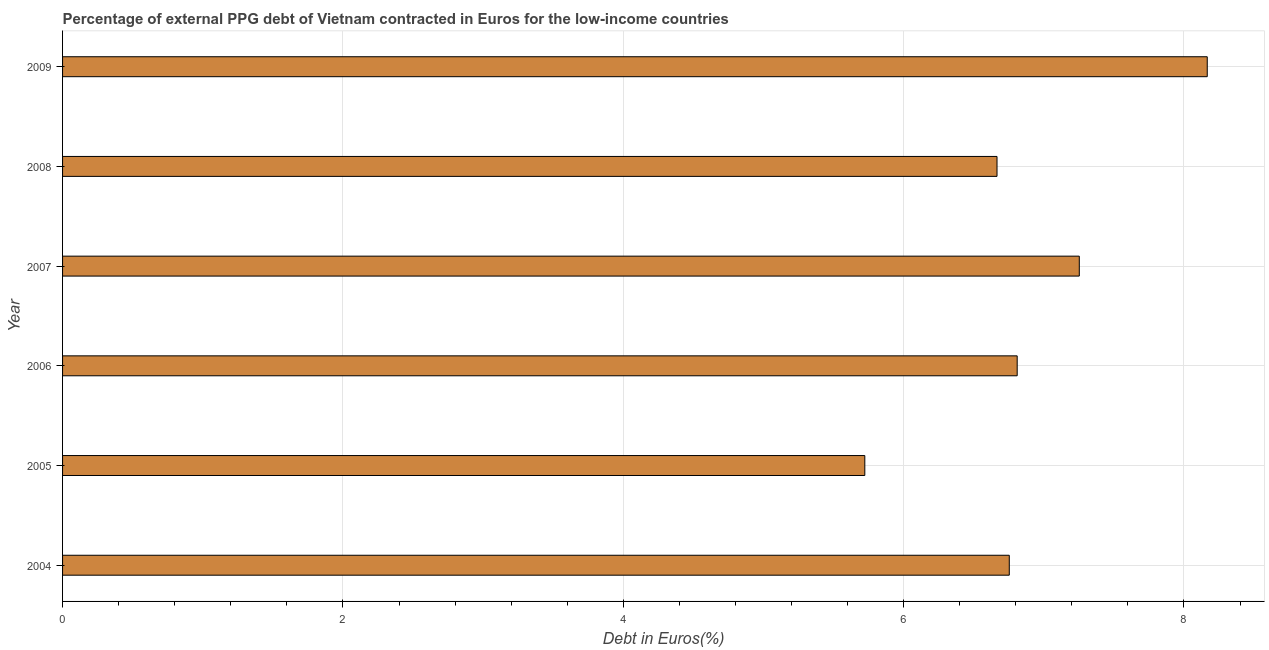Does the graph contain any zero values?
Your answer should be compact. No. Does the graph contain grids?
Give a very brief answer. Yes. What is the title of the graph?
Provide a succinct answer. Percentage of external PPG debt of Vietnam contracted in Euros for the low-income countries. What is the label or title of the X-axis?
Offer a terse response. Debt in Euros(%). What is the label or title of the Y-axis?
Ensure brevity in your answer.  Year. What is the currency composition of ppg debt in 2009?
Give a very brief answer. 8.17. Across all years, what is the maximum currency composition of ppg debt?
Provide a short and direct response. 8.17. Across all years, what is the minimum currency composition of ppg debt?
Your answer should be compact. 5.72. What is the sum of the currency composition of ppg debt?
Offer a terse response. 41.37. What is the difference between the currency composition of ppg debt in 2004 and 2008?
Ensure brevity in your answer.  0.09. What is the average currency composition of ppg debt per year?
Your answer should be compact. 6.89. What is the median currency composition of ppg debt?
Your answer should be compact. 6.78. What is the ratio of the currency composition of ppg debt in 2005 to that in 2006?
Your answer should be very brief. 0.84. Is the currency composition of ppg debt in 2007 less than that in 2009?
Your answer should be very brief. Yes. What is the difference between the highest and the second highest currency composition of ppg debt?
Your response must be concise. 0.91. Is the sum of the currency composition of ppg debt in 2004 and 2009 greater than the maximum currency composition of ppg debt across all years?
Offer a very short reply. Yes. What is the difference between the highest and the lowest currency composition of ppg debt?
Keep it short and to the point. 2.44. What is the Debt in Euros(%) of 2004?
Give a very brief answer. 6.75. What is the Debt in Euros(%) in 2005?
Provide a succinct answer. 5.72. What is the Debt in Euros(%) in 2006?
Provide a short and direct response. 6.81. What is the Debt in Euros(%) of 2007?
Offer a very short reply. 7.25. What is the Debt in Euros(%) of 2008?
Your answer should be compact. 6.67. What is the Debt in Euros(%) of 2009?
Your response must be concise. 8.17. What is the difference between the Debt in Euros(%) in 2004 and 2005?
Provide a short and direct response. 1.03. What is the difference between the Debt in Euros(%) in 2004 and 2006?
Your answer should be compact. -0.06. What is the difference between the Debt in Euros(%) in 2004 and 2007?
Make the answer very short. -0.5. What is the difference between the Debt in Euros(%) in 2004 and 2008?
Keep it short and to the point. 0.09. What is the difference between the Debt in Euros(%) in 2004 and 2009?
Provide a succinct answer. -1.41. What is the difference between the Debt in Euros(%) in 2005 and 2006?
Ensure brevity in your answer.  -1.09. What is the difference between the Debt in Euros(%) in 2005 and 2007?
Offer a terse response. -1.53. What is the difference between the Debt in Euros(%) in 2005 and 2008?
Give a very brief answer. -0.94. What is the difference between the Debt in Euros(%) in 2005 and 2009?
Your answer should be compact. -2.44. What is the difference between the Debt in Euros(%) in 2006 and 2007?
Ensure brevity in your answer.  -0.44. What is the difference between the Debt in Euros(%) in 2006 and 2008?
Keep it short and to the point. 0.14. What is the difference between the Debt in Euros(%) in 2006 and 2009?
Your answer should be compact. -1.36. What is the difference between the Debt in Euros(%) in 2007 and 2008?
Offer a terse response. 0.59. What is the difference between the Debt in Euros(%) in 2007 and 2009?
Keep it short and to the point. -0.91. What is the difference between the Debt in Euros(%) in 2008 and 2009?
Offer a very short reply. -1.5. What is the ratio of the Debt in Euros(%) in 2004 to that in 2005?
Your response must be concise. 1.18. What is the ratio of the Debt in Euros(%) in 2004 to that in 2006?
Your answer should be compact. 0.99. What is the ratio of the Debt in Euros(%) in 2004 to that in 2008?
Give a very brief answer. 1.01. What is the ratio of the Debt in Euros(%) in 2004 to that in 2009?
Offer a very short reply. 0.83. What is the ratio of the Debt in Euros(%) in 2005 to that in 2006?
Provide a succinct answer. 0.84. What is the ratio of the Debt in Euros(%) in 2005 to that in 2007?
Offer a terse response. 0.79. What is the ratio of the Debt in Euros(%) in 2005 to that in 2008?
Provide a short and direct response. 0.86. What is the ratio of the Debt in Euros(%) in 2005 to that in 2009?
Keep it short and to the point. 0.7. What is the ratio of the Debt in Euros(%) in 2006 to that in 2007?
Offer a very short reply. 0.94. What is the ratio of the Debt in Euros(%) in 2006 to that in 2009?
Keep it short and to the point. 0.83. What is the ratio of the Debt in Euros(%) in 2007 to that in 2008?
Your answer should be compact. 1.09. What is the ratio of the Debt in Euros(%) in 2007 to that in 2009?
Keep it short and to the point. 0.89. What is the ratio of the Debt in Euros(%) in 2008 to that in 2009?
Offer a terse response. 0.82. 